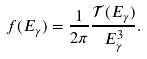Convert formula to latex. <formula><loc_0><loc_0><loc_500><loc_500>f ( E _ { \gamma } ) = \frac { 1 } { 2 \pi } \frac { { \mathcal { T } } ( E _ { \gamma } ) } { E _ { \gamma } ^ { 3 } } .</formula> 